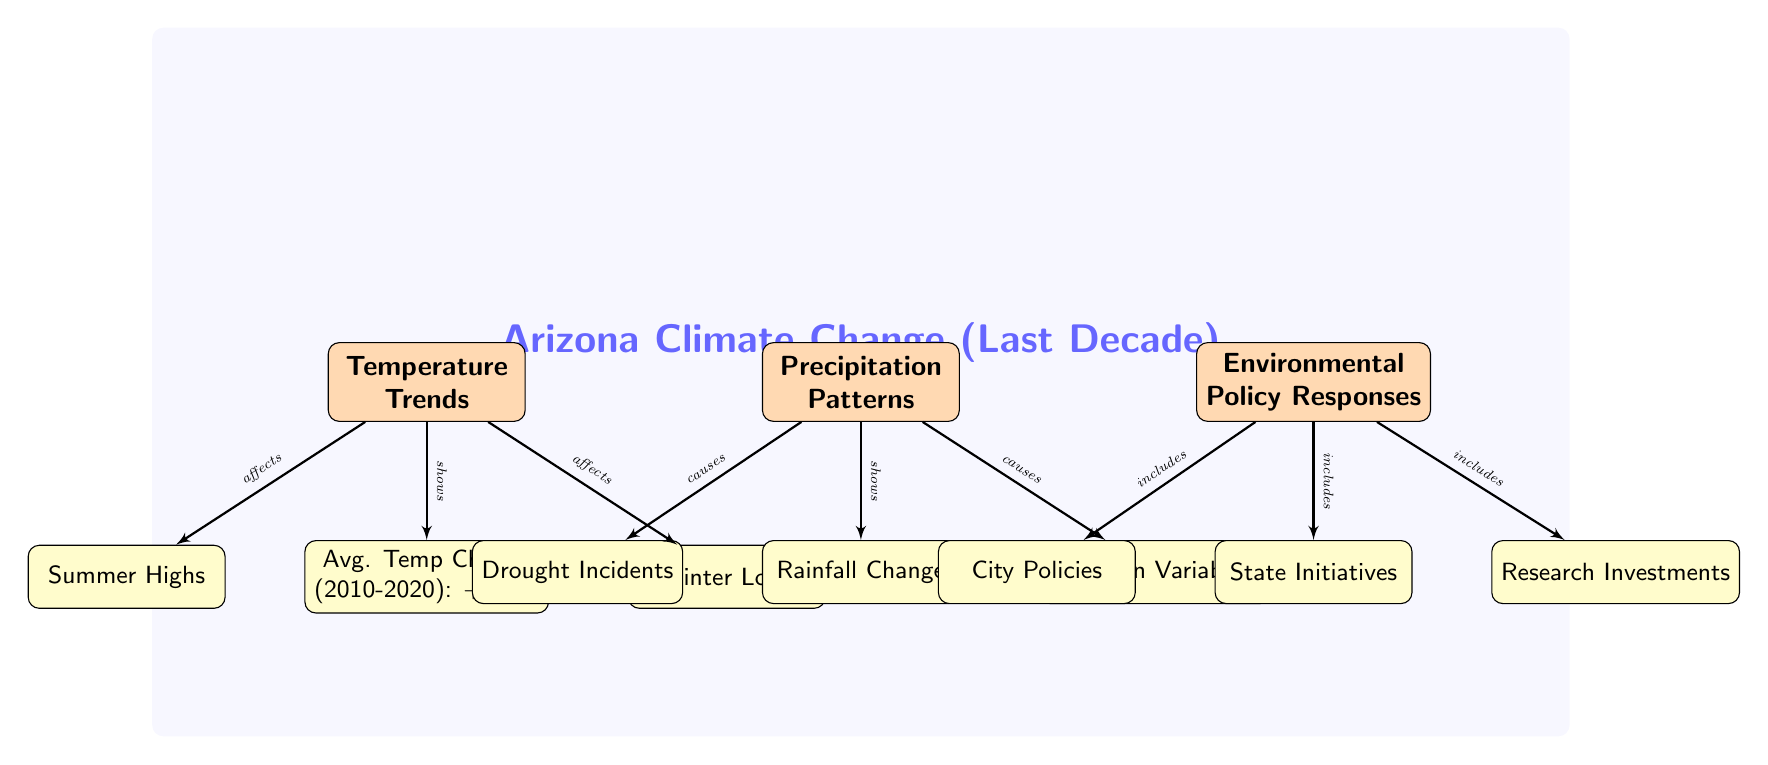What is the average temperature change in Arizona from 2010 to 2020? The diagram states that the average temperature change over this decade is +1.5°F. This value is highlighted within the "Temperature Trends" section as a key detail.
Answer: +1.5°F What component affects summer highs? The diagram indicates a direct connection from "Temperature Trends" to "Summer Highs," showing that temperature trends have an effect on summer high temperatures.
Answer: Temperature Trends How many sub-nodes are related to precipitation patterns? The diagram includes three sub-nodes under "Precipitation Patterns": "Rainfall Change," "Drought Incidents," and "Monsoon Variability," totaling three sub-nodes connected to precipitation patterns.
Answer: 3 Which policy category includes research investments? The connection from "Environmental Policy Responses" to "Research Investments" indicates that this element is part of the overall environmental policy responses explored in the diagram.
Answer: Environmental Policy Responses How do precipitation patterns affect drought incidents? The diagram shows that precipitation patterns cause drought incidents, establishing a cause-and-effect relationship. This indicates that changes in precipitation can lead to an increase in drought occurrences.
Answer: Drought Incidents What is shown under the rainfall change sub-node? Under "Precipitation Patterns," the sub-node "Rainfall Change" is present, displaying a direct connection from it. This node summarizes a crucial aspect of precipitation patterns in Arizona.
Answer: Rainfall Change What color represents the main nodes in the diagram? The main nodes are indicated in orange, as seen in the color coding of "Temperature Trends," "Precipitation Patterns," and "Environmental Policy Responses."
Answer: Orange Which sub-node pertains to summer temperatures? The diagram specifies "Summer Highs" as a sub-node under "Temperature Trends," indicating its relevance to summer temperatures in Arizona.
Answer: Summer Highs What do the edges indicate about the relationships in the diagram? The edges indicate specific relationships such as "shows," "affects," "causes," and "includes," clarifying interactions between main nodes and their respective sub-nodes.
Answer: Relationships 